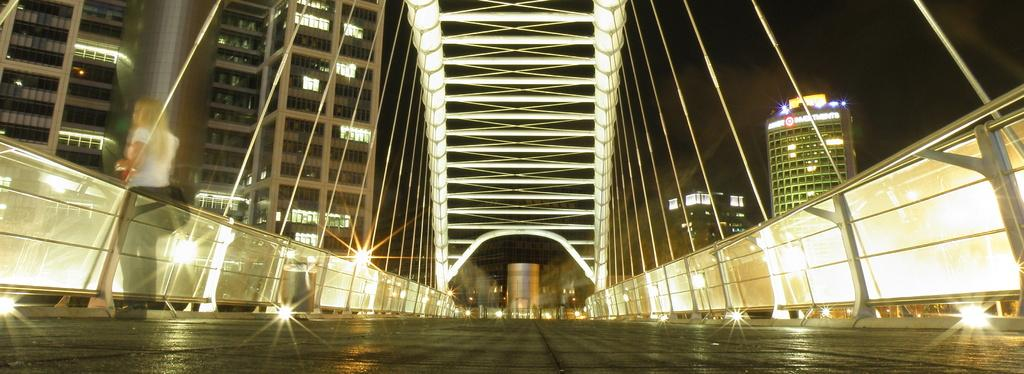What is the main feature of the image? There is a road in the image. What is located next to the road? There is a railing next to the road. What can be seen in the distance in the image? There are many buildings and lights visible in the background. What is visible above the buildings and lights? The sky is visible in the background of the image. What type of stamp can be seen on the aftermath of the idea in the image? There is no stamp, aftermath, or idea present in the image. 